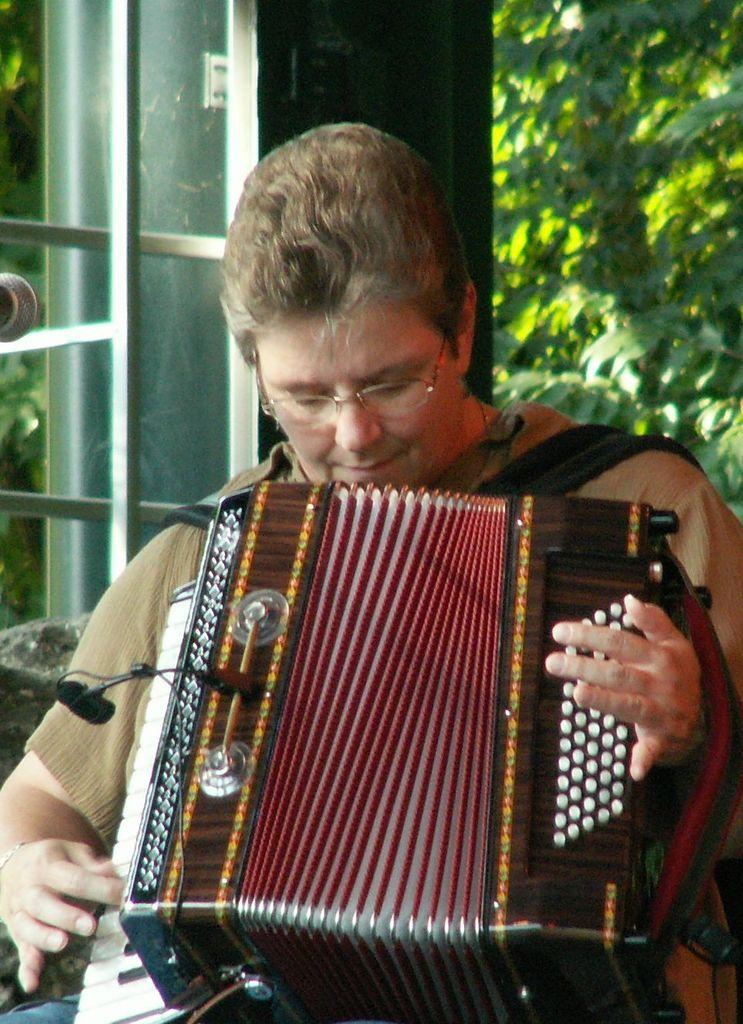What is the main subject of the image? There is a person in the image. What is the person holding in the image? The person is holding a musical instrument. What color is the shirt the person is wearing? The person is wearing a black shirt. What can be seen in the background of the image? There is a window and trees with green color in the background of the image. What type of steel is being tested in the image? There is no steel or testing activity present in the image. What hobbies does the person in the image have? We cannot determine the person's hobbies from the image alone, as it only shows them holding a musical instrument. 